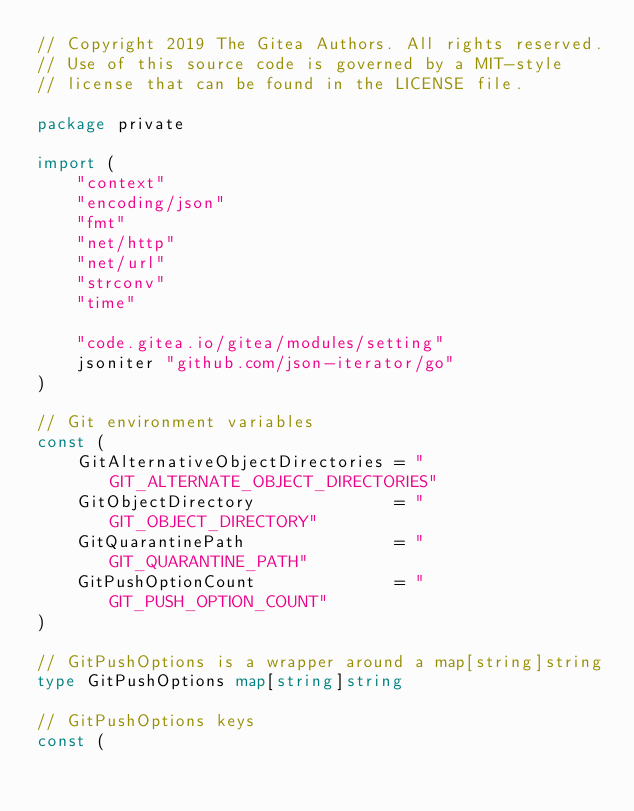<code> <loc_0><loc_0><loc_500><loc_500><_Go_>// Copyright 2019 The Gitea Authors. All rights reserved.
// Use of this source code is governed by a MIT-style
// license that can be found in the LICENSE file.

package private

import (
	"context"
	"encoding/json"
	"fmt"
	"net/http"
	"net/url"
	"strconv"
	"time"

	"code.gitea.io/gitea/modules/setting"
	jsoniter "github.com/json-iterator/go"
)

// Git environment variables
const (
	GitAlternativeObjectDirectories = "GIT_ALTERNATE_OBJECT_DIRECTORIES"
	GitObjectDirectory              = "GIT_OBJECT_DIRECTORY"
	GitQuarantinePath               = "GIT_QUARANTINE_PATH"
	GitPushOptionCount              = "GIT_PUSH_OPTION_COUNT"
)

// GitPushOptions is a wrapper around a map[string]string
type GitPushOptions map[string]string

// GitPushOptions keys
const (</code> 